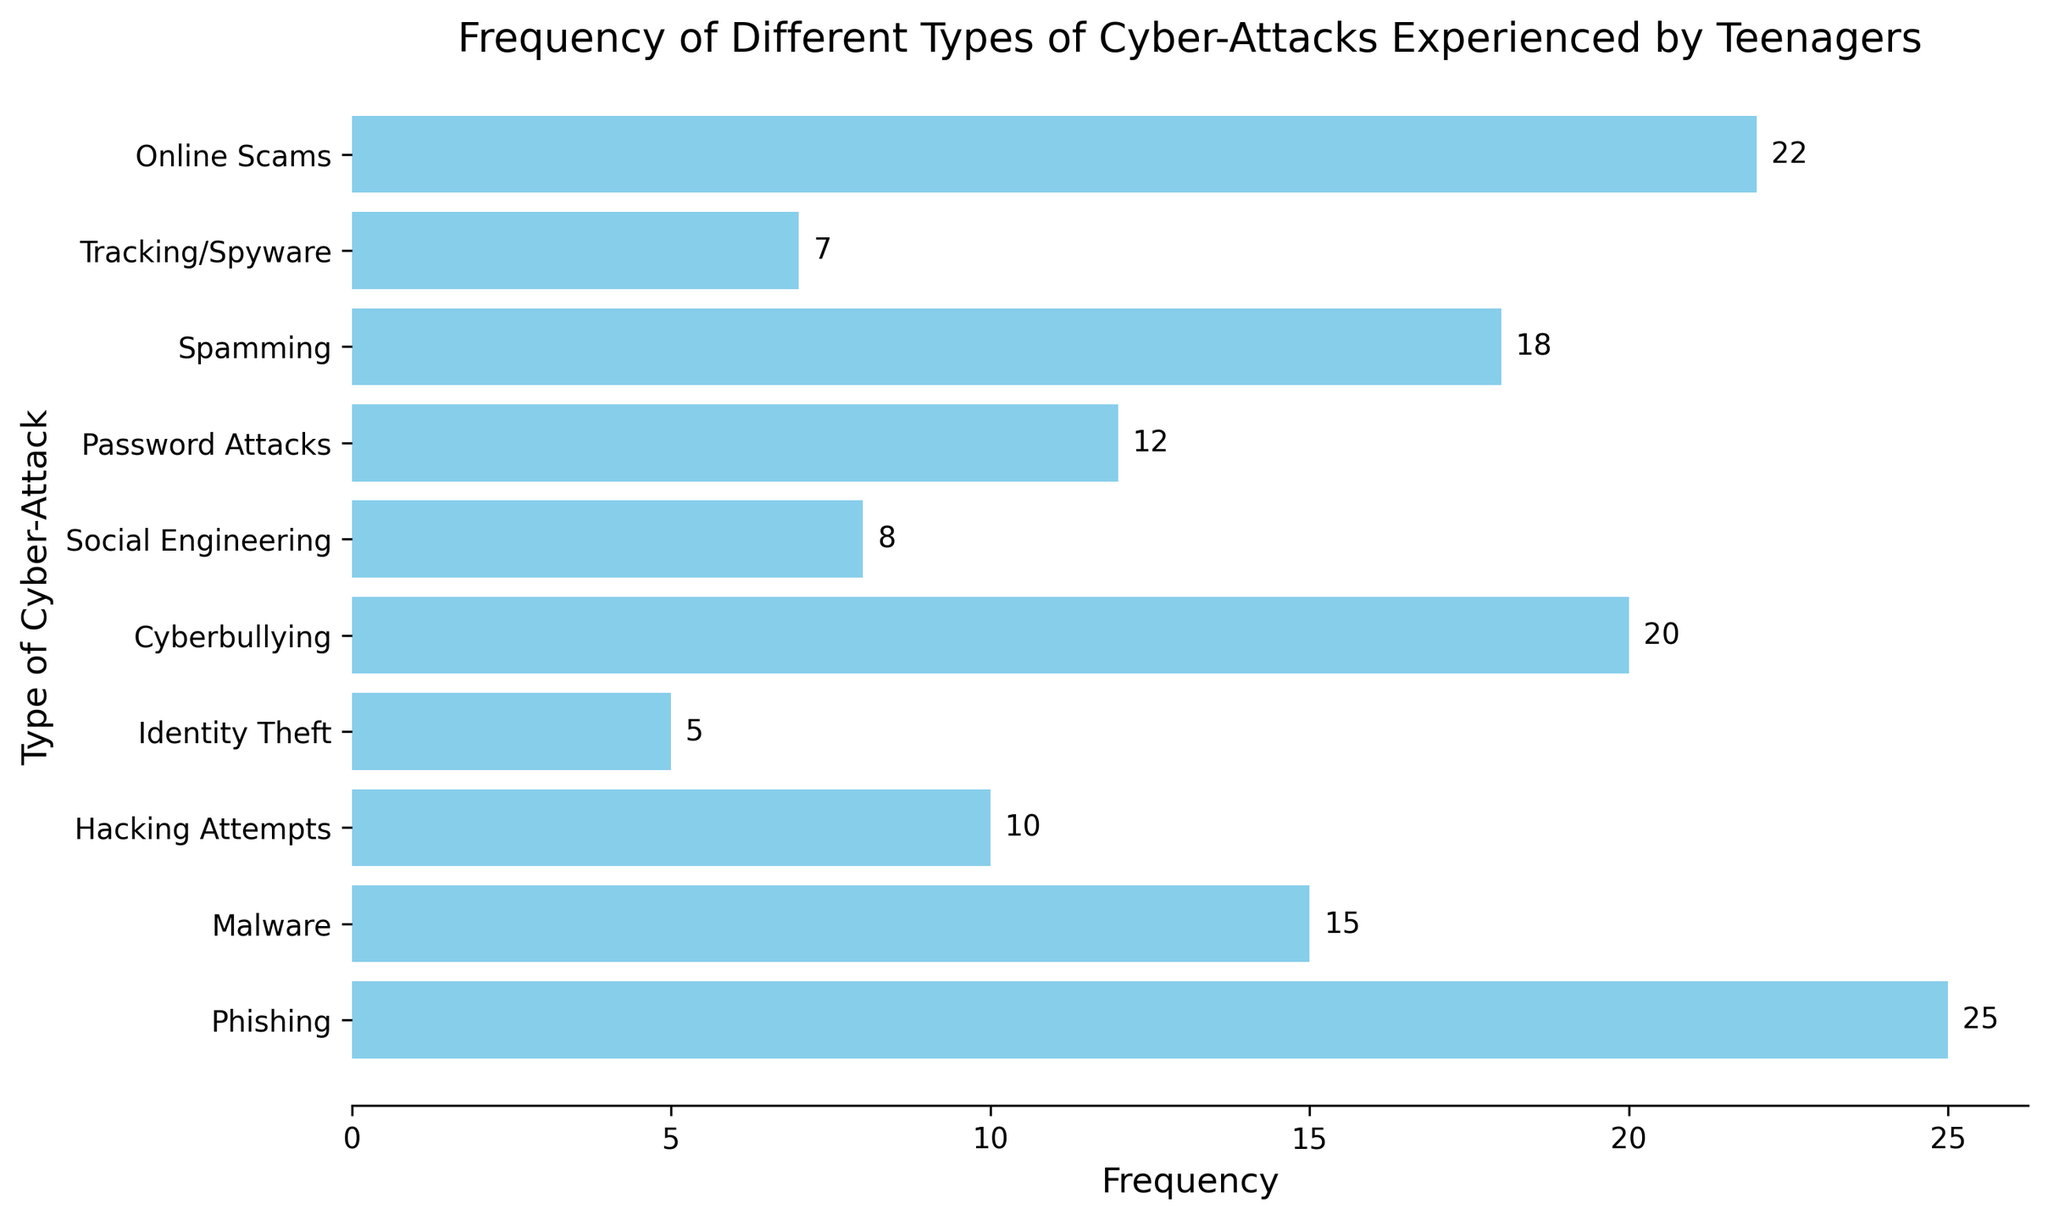Which type of cyber-attack is the most frequent among teenagers? By looking at the bar lengths, the "Phishing" bar is the longest, indicating it has the highest frequency among the listed types of cyber-attacks.
Answer: Phishing Which two types of cyber-attacks have a combined frequency of 40? Add the frequencies for each type of cyber-attack and find the pairs that sum up to 40: Phishing (25) + Malware (15) = 40.
Answer: Phishing and Malware How does the frequency of Password Attacks compare to Cyberbullying? Compare the lengths of the "Password Attacks" bar and the "Cyberbullying" bar. Password Attacks have a frequency of 12, whereas Cyberbullying has 20. Cyberbullying is more frequent.
Answer: Cyberbullying is more frequent What is the difference in frequency between Spamming and Online Scams? Subtract the frequency of Online Scams from Spamming. Spamming has a frequency of 18, and Online Scams have 22. Therefore, the difference is 22 - 18 = 4.
Answer: 4 Which type of cyber-attack has a frequency closest to the average frequency? Find the average frequency first by summing all frequencies and dividing by the number of types: (25 + 15 + 10 + 5 + 20 + 8 + 12 + 18 + 7 + 22) / 10 = 14.2. The frequency closest to 14.2 is Malware (15).
Answer: Malware Rank the cyber-attacks in order of frequency from highest to lowest. Visually compare the bar lengths from left to right to rank them: Phishing, Online Scams, Cyberbullying, Spamming, Malware, Password Attacks, Hacking Attempts, Social Engineering, Tracking/Spyware, Identity Theft.
Answer: Phishing, Online Scams, Cyberbullying, Spamming, Malware, Password Attacks, Hacking Attempts, Social Engineering, Tracking/Spyware, Identity Theft If you remove the top two most frequent attacks, what is the new average frequency? Identify and remove the frequencies of the top two attacks: Phishing (25) and Online Scams (22). Recalculate the average with the remaining frequencies: (15 + 10 + 5 + 20 + 8 + 12 + 18 + 7) / 8 = 11.875.
Answer: 11.875 Which cyber-attack types have a frequency greater than 10 but less than 20? Identify the types within the specified frequency range by referring to the bar lengths: Cyberbullying (20), Spamming (18), Password Attacks (12) and Malware (15).
Answer: Malware, Password Attacks, Spamming, Cyberbullying 